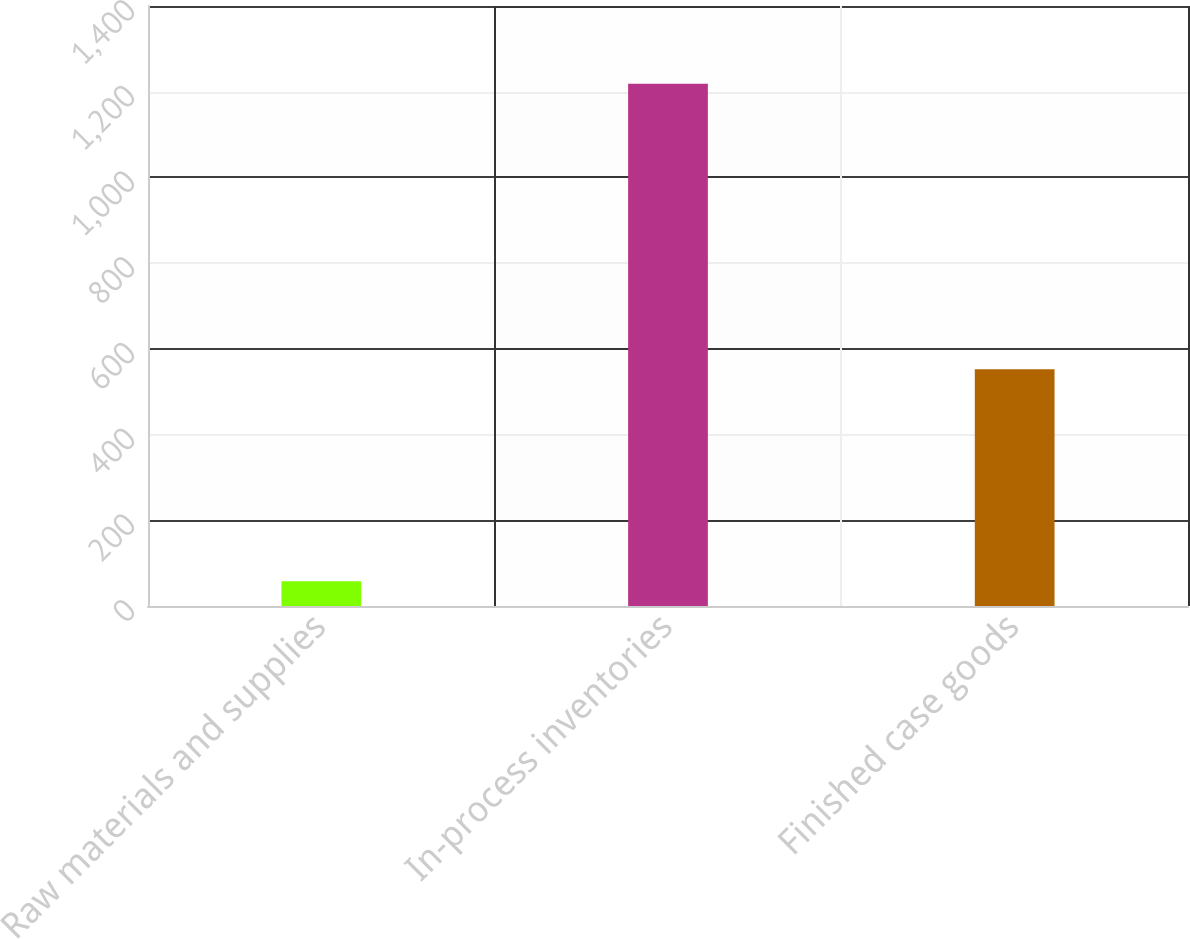<chart> <loc_0><loc_0><loc_500><loc_500><bar_chart><fcel>Raw materials and supplies<fcel>In-process inventories<fcel>Finished case goods<nl><fcel>57.9<fcel>1218.4<fcel>552.4<nl></chart> 